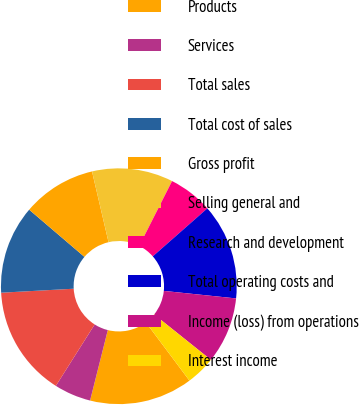<chart> <loc_0><loc_0><loc_500><loc_500><pie_chart><fcel>Products<fcel>Services<fcel>Total sales<fcel>Total cost of sales<fcel>Gross profit<fcel>Selling general and<fcel>Research and development<fcel>Total operating costs and<fcel>Income (loss) from operations<fcel>Interest income<nl><fcel>14.14%<fcel>5.05%<fcel>15.15%<fcel>12.12%<fcel>10.1%<fcel>11.11%<fcel>6.06%<fcel>13.13%<fcel>9.09%<fcel>4.04%<nl></chart> 